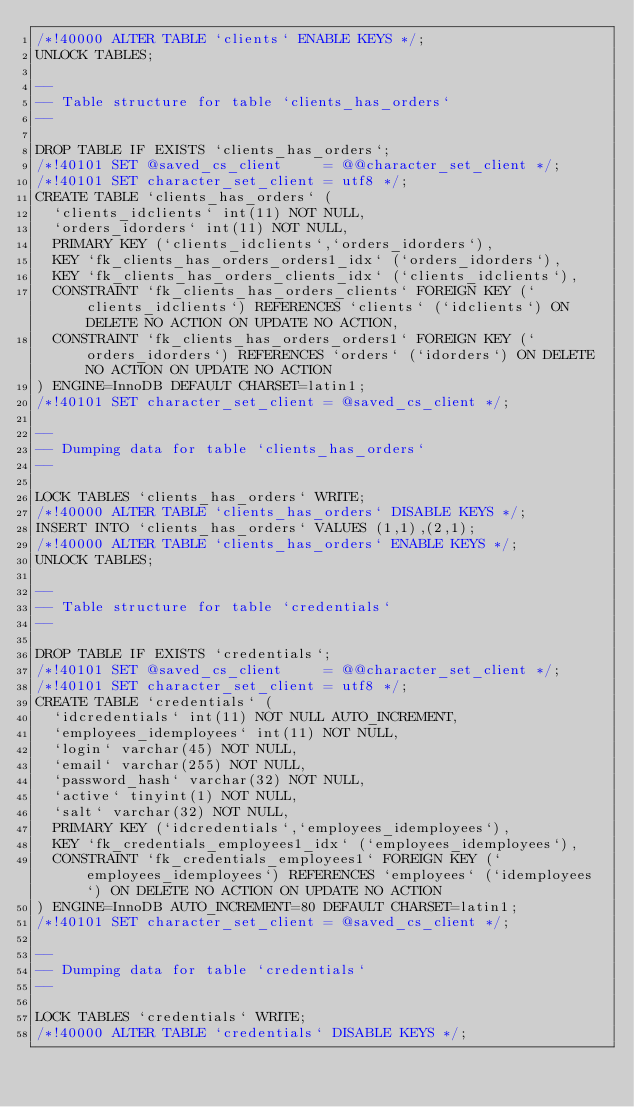<code> <loc_0><loc_0><loc_500><loc_500><_SQL_>/*!40000 ALTER TABLE `clients` ENABLE KEYS */;
UNLOCK TABLES;

--
-- Table structure for table `clients_has_orders`
--

DROP TABLE IF EXISTS `clients_has_orders`;
/*!40101 SET @saved_cs_client     = @@character_set_client */;
/*!40101 SET character_set_client = utf8 */;
CREATE TABLE `clients_has_orders` (
  `clients_idclients` int(11) NOT NULL,
  `orders_idorders` int(11) NOT NULL,
  PRIMARY KEY (`clients_idclients`,`orders_idorders`),
  KEY `fk_clients_has_orders_orders1_idx` (`orders_idorders`),
  KEY `fk_clients_has_orders_clients_idx` (`clients_idclients`),
  CONSTRAINT `fk_clients_has_orders_clients` FOREIGN KEY (`clients_idclients`) REFERENCES `clients` (`idclients`) ON DELETE NO ACTION ON UPDATE NO ACTION,
  CONSTRAINT `fk_clients_has_orders_orders1` FOREIGN KEY (`orders_idorders`) REFERENCES `orders` (`idorders`) ON DELETE NO ACTION ON UPDATE NO ACTION
) ENGINE=InnoDB DEFAULT CHARSET=latin1;
/*!40101 SET character_set_client = @saved_cs_client */;

--
-- Dumping data for table `clients_has_orders`
--

LOCK TABLES `clients_has_orders` WRITE;
/*!40000 ALTER TABLE `clients_has_orders` DISABLE KEYS */;
INSERT INTO `clients_has_orders` VALUES (1,1),(2,1);
/*!40000 ALTER TABLE `clients_has_orders` ENABLE KEYS */;
UNLOCK TABLES;

--
-- Table structure for table `credentials`
--

DROP TABLE IF EXISTS `credentials`;
/*!40101 SET @saved_cs_client     = @@character_set_client */;
/*!40101 SET character_set_client = utf8 */;
CREATE TABLE `credentials` (
  `idcredentials` int(11) NOT NULL AUTO_INCREMENT,
  `employees_idemployees` int(11) NOT NULL,
  `login` varchar(45) NOT NULL,
  `email` varchar(255) NOT NULL,
  `password_hash` varchar(32) NOT NULL,
  `active` tinyint(1) NOT NULL,
  `salt` varchar(32) NOT NULL,
  PRIMARY KEY (`idcredentials`,`employees_idemployees`),
  KEY `fk_credentials_employees1_idx` (`employees_idemployees`),
  CONSTRAINT `fk_credentials_employees1` FOREIGN KEY (`employees_idemployees`) REFERENCES `employees` (`idemployees`) ON DELETE NO ACTION ON UPDATE NO ACTION
) ENGINE=InnoDB AUTO_INCREMENT=80 DEFAULT CHARSET=latin1;
/*!40101 SET character_set_client = @saved_cs_client */;

--
-- Dumping data for table `credentials`
--

LOCK TABLES `credentials` WRITE;
/*!40000 ALTER TABLE `credentials` DISABLE KEYS */;</code> 